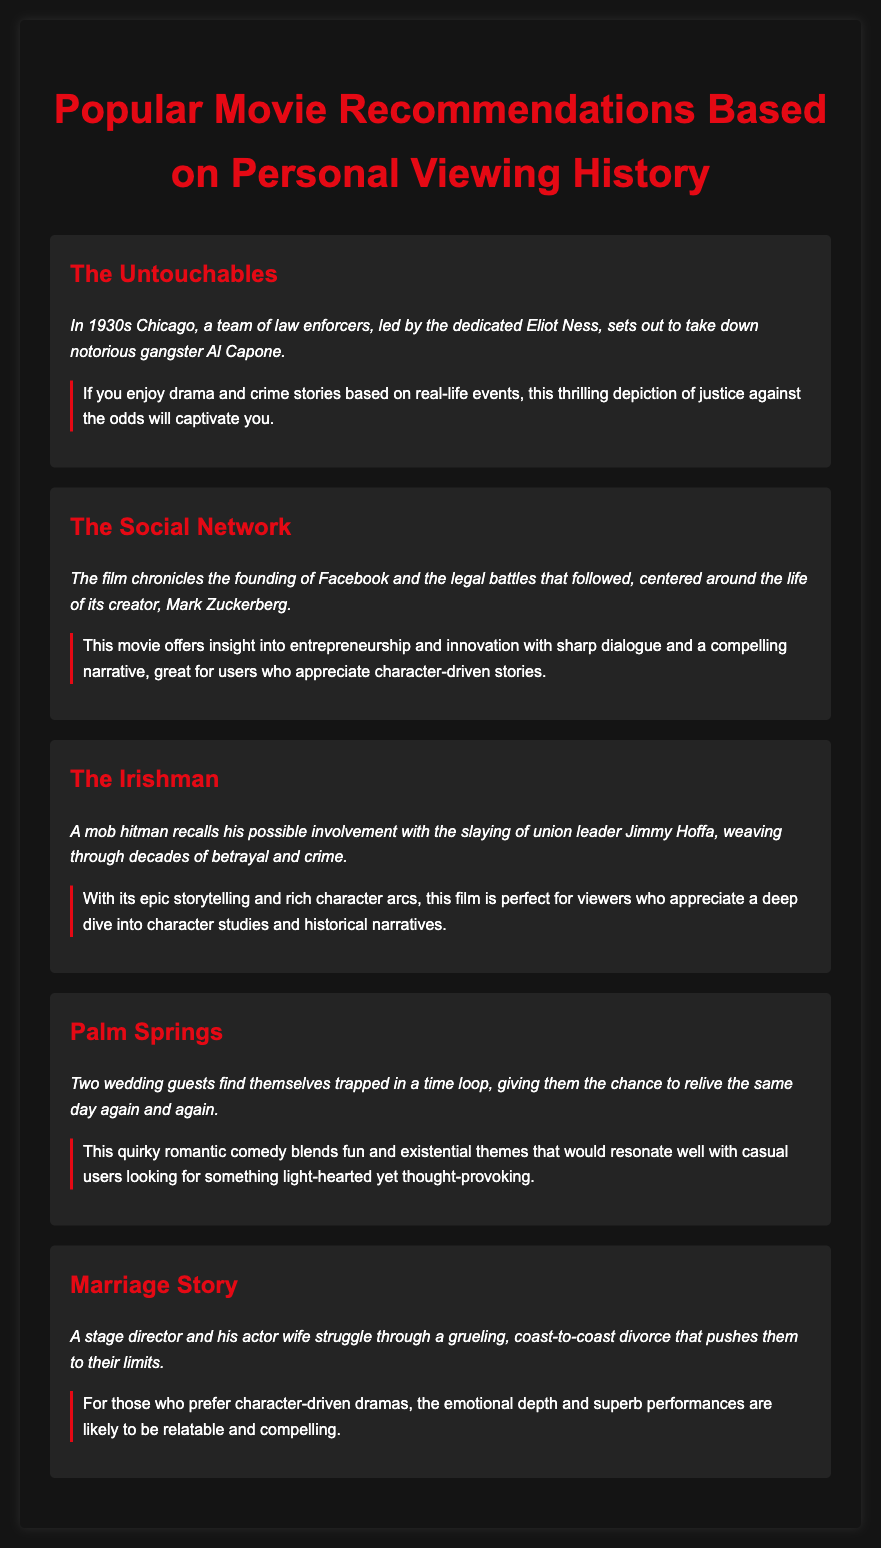What is the title of the first movie listed? The title of the first movie in the document is stated at the beginning of its section.
Answer: The Untouchables What is the main theme of "The Social Network"? The document explains that the movie chronicles the founding of Facebook and the legal battles that followed.
Answer: Entrepreneurship and innovation Which movie features a time loop scenario? The document describes a film where characters relive the same day multiple times.
Answer: Palm Springs How many movies are listed in total? The document counts the individual movie sections to determine the total.
Answer: Five Which film is described as a character-driven drama about divorce? The description in the document clearly identifies the film focused on a grueling divorce.
Answer: Marriage Story What common genre do "The Untouchables" and "The Irishman" share? Both movies are described with a connection to crime and real-life events within their synopses.
Answer: Crime What unique aspect of "Palm Springs" is highlighted? The document emphasizes the quirky nature of the film and its light-hearted yet thought-provoking themes.
Answer: Time loop and existential themes Which movie features a character named Mark Zuckerberg? The document makes a specific reference to the character during the synopsis of its corresponding movie.
Answer: The Social Network 